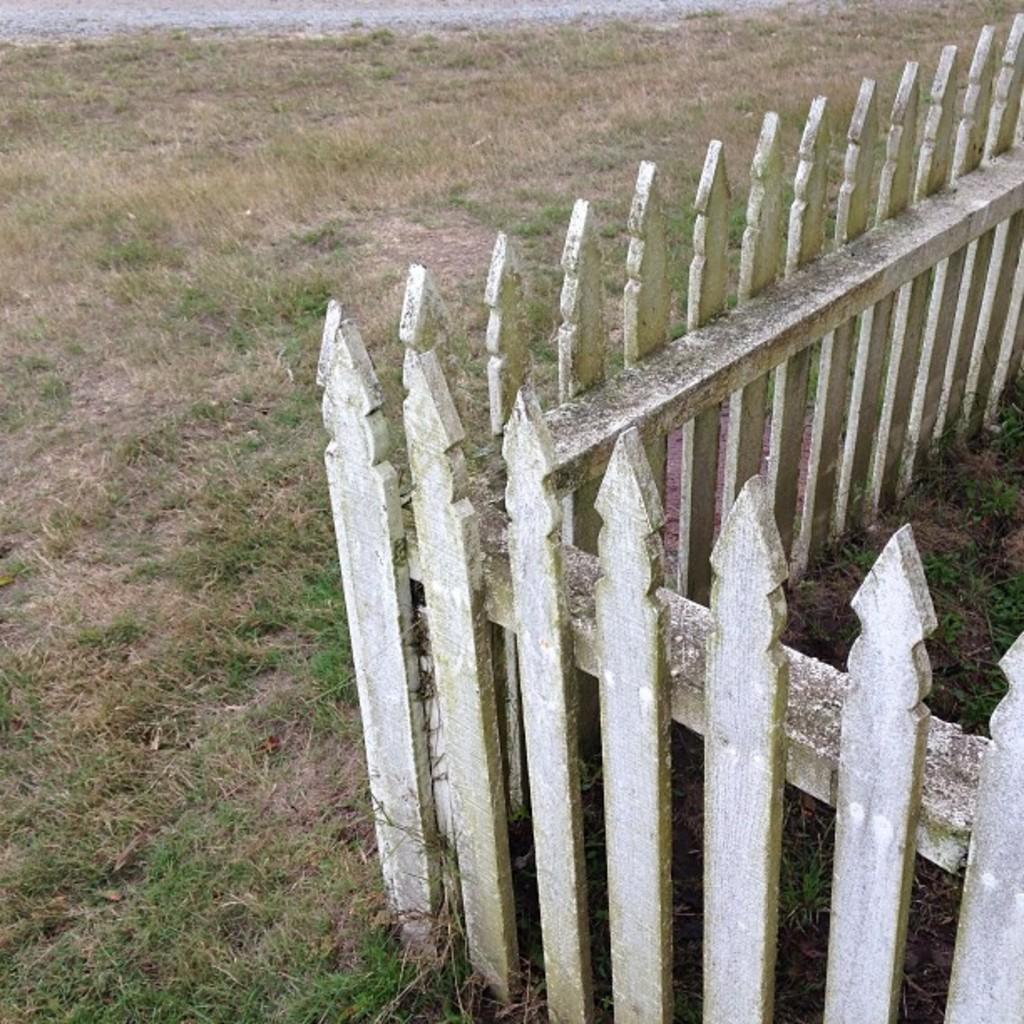What type of terrain is visible in the image? There is ground with grass in the image. What structure can be seen in the image? There is fencing in the image. Can you see a squirrel holding a letter while whistling in the image? There is no squirrel, letter, or whistling activity present in the image. 